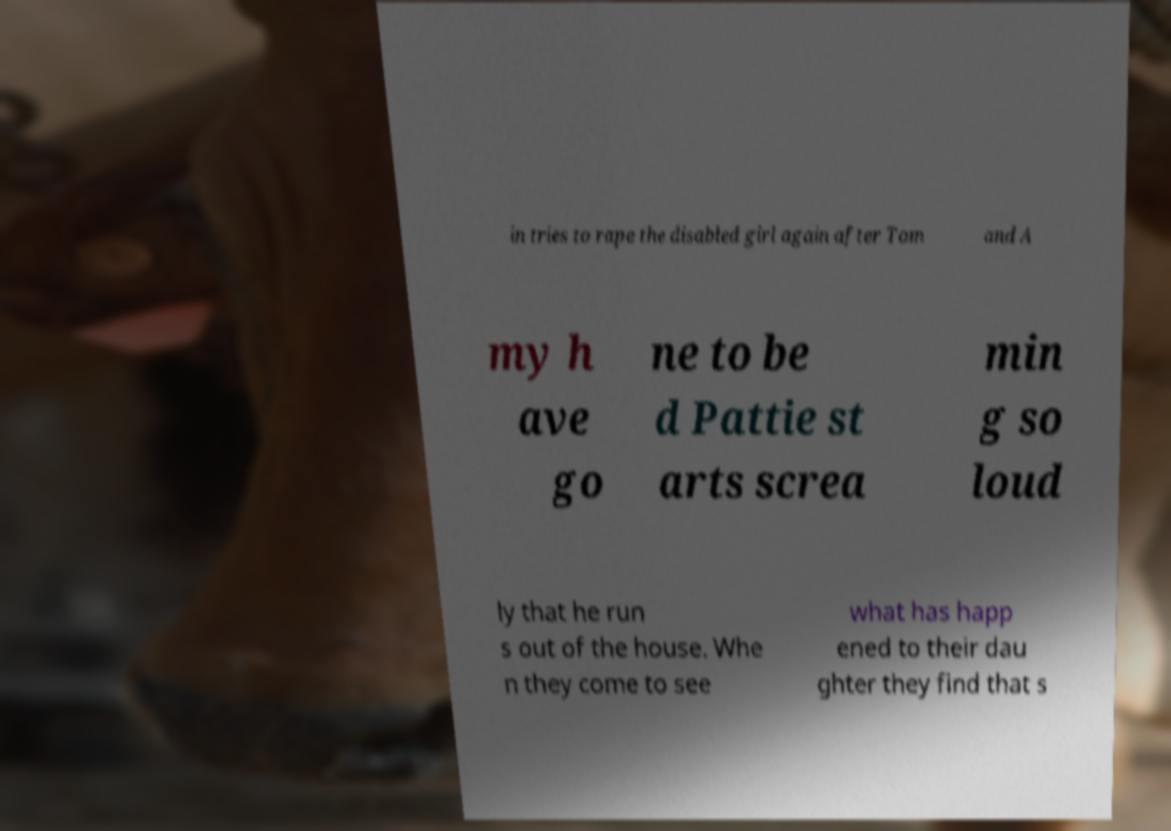Please read and relay the text visible in this image. What does it say? in tries to rape the disabled girl again after Tom and A my h ave go ne to be d Pattie st arts screa min g so loud ly that he run s out of the house. Whe n they come to see what has happ ened to their dau ghter they find that s 